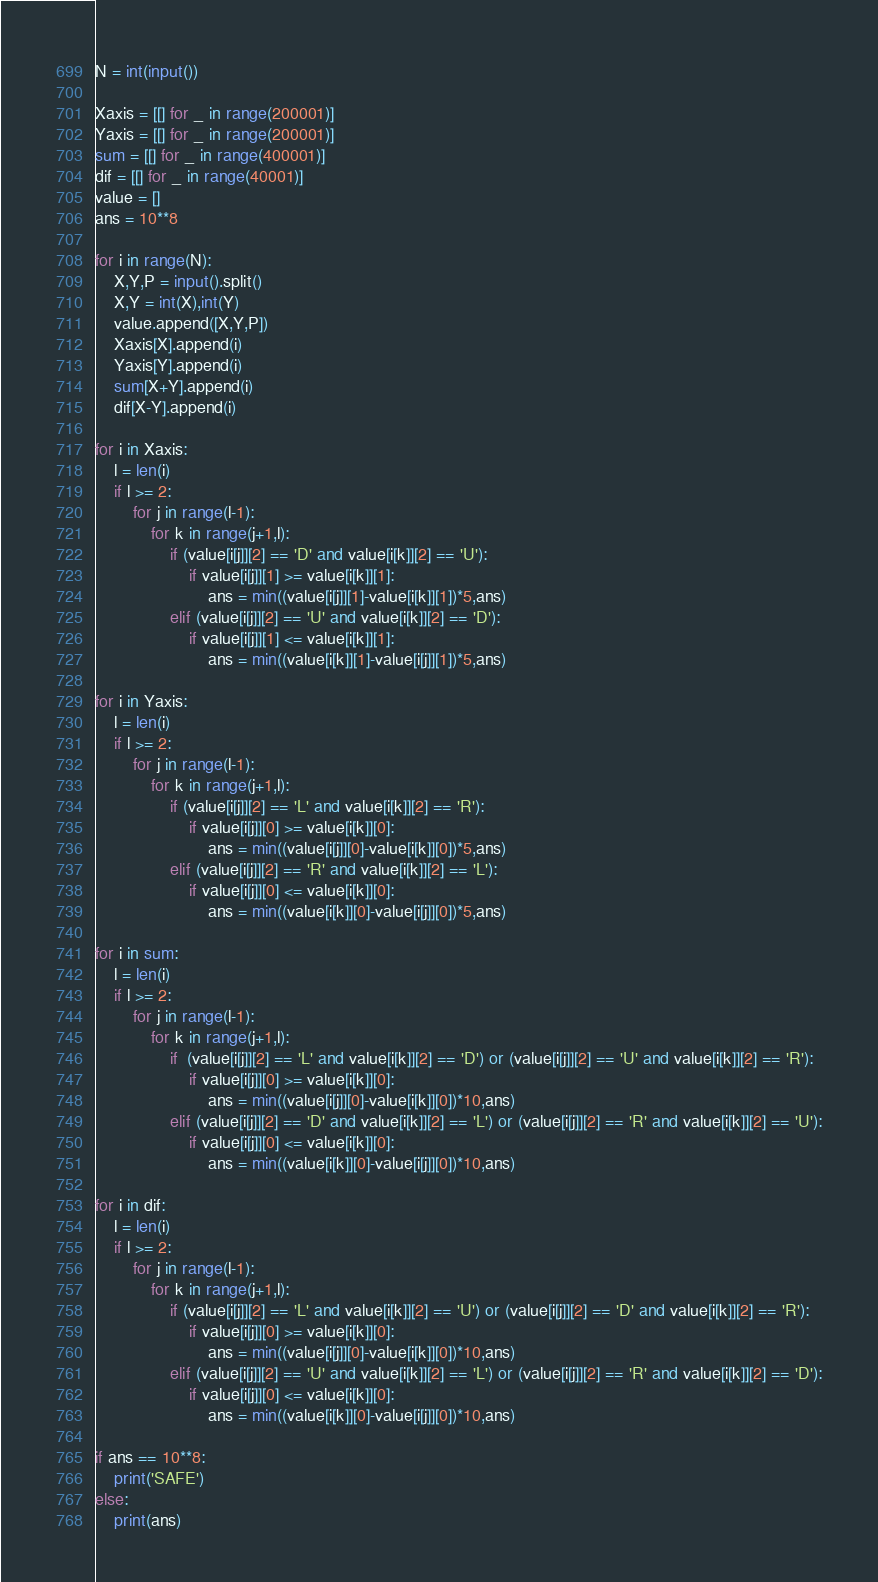Convert code to text. <code><loc_0><loc_0><loc_500><loc_500><_Python_>N = int(input())

Xaxis = [[] for _ in range(200001)]
Yaxis = [[] for _ in range(200001)]
sum = [[] for _ in range(400001)]
dif = [[] for _ in range(40001)]
value = []
ans = 10**8

for i in range(N):
    X,Y,P = input().split()
    X,Y = int(X),int(Y)
    value.append([X,Y,P])
    Xaxis[X].append(i)
    Yaxis[Y].append(i)
    sum[X+Y].append(i)
    dif[X-Y].append(i)

for i in Xaxis:
    l = len(i)
    if l >= 2:
        for j in range(l-1):
            for k in range(j+1,l):
                if (value[i[j]][2] == 'D' and value[i[k]][2] == 'U'):
                    if value[i[j]][1] >= value[i[k]][1]:
                        ans = min((value[i[j]][1]-value[i[k]][1])*5,ans)
                elif (value[i[j]][2] == 'U' and value[i[k]][2] == 'D'):
                    if value[i[j]][1] <= value[i[k]][1]:
                        ans = min((value[i[k]][1]-value[i[j]][1])*5,ans)

for i in Yaxis:
    l = len(i)
    if l >= 2:
        for j in range(l-1):
            for k in range(j+1,l):
                if (value[i[j]][2] == 'L' and value[i[k]][2] == 'R'):
                    if value[i[j]][0] >= value[i[k]][0]:
                        ans = min((value[i[j]][0]-value[i[k]][0])*5,ans)
                elif (value[i[j]][2] == 'R' and value[i[k]][2] == 'L'):
                    if value[i[j]][0] <= value[i[k]][0]:
                        ans = min((value[i[k]][0]-value[i[j]][0])*5,ans)

for i in sum:
    l = len(i)
    if l >= 2:
        for j in range(l-1):
            for k in range(j+1,l):
                if  (value[i[j]][2] == 'L' and value[i[k]][2] == 'D') or (value[i[j]][2] == 'U' and value[i[k]][2] == 'R'):
                    if value[i[j]][0] >= value[i[k]][0]:
                        ans = min((value[i[j]][0]-value[i[k]][0])*10,ans)
                elif (value[i[j]][2] == 'D' and value[i[k]][2] == 'L') or (value[i[j]][2] == 'R' and value[i[k]][2] == 'U'):
                    if value[i[j]][0] <= value[i[k]][0]:
                        ans = min((value[i[k]][0]-value[i[j]][0])*10,ans)

for i in dif:
    l = len(i)
    if l >= 2:
        for j in range(l-1):
            for k in range(j+1,l):
                if (value[i[j]][2] == 'L' and value[i[k]][2] == 'U') or (value[i[j]][2] == 'D' and value[i[k]][2] == 'R'):
                    if value[i[j]][0] >= value[i[k]][0]:
                        ans = min((value[i[j]][0]-value[i[k]][0])*10,ans)
                elif (value[i[j]][2] == 'U' and value[i[k]][2] == 'L') or (value[i[j]][2] == 'R' and value[i[k]][2] == 'D'):
                    if value[i[j]][0] <= value[i[k]][0]:
                        ans = min((value[i[k]][0]-value[i[j]][0])*10,ans)

if ans == 10**8:
    print('SAFE')
else:
    print(ans)
</code> 